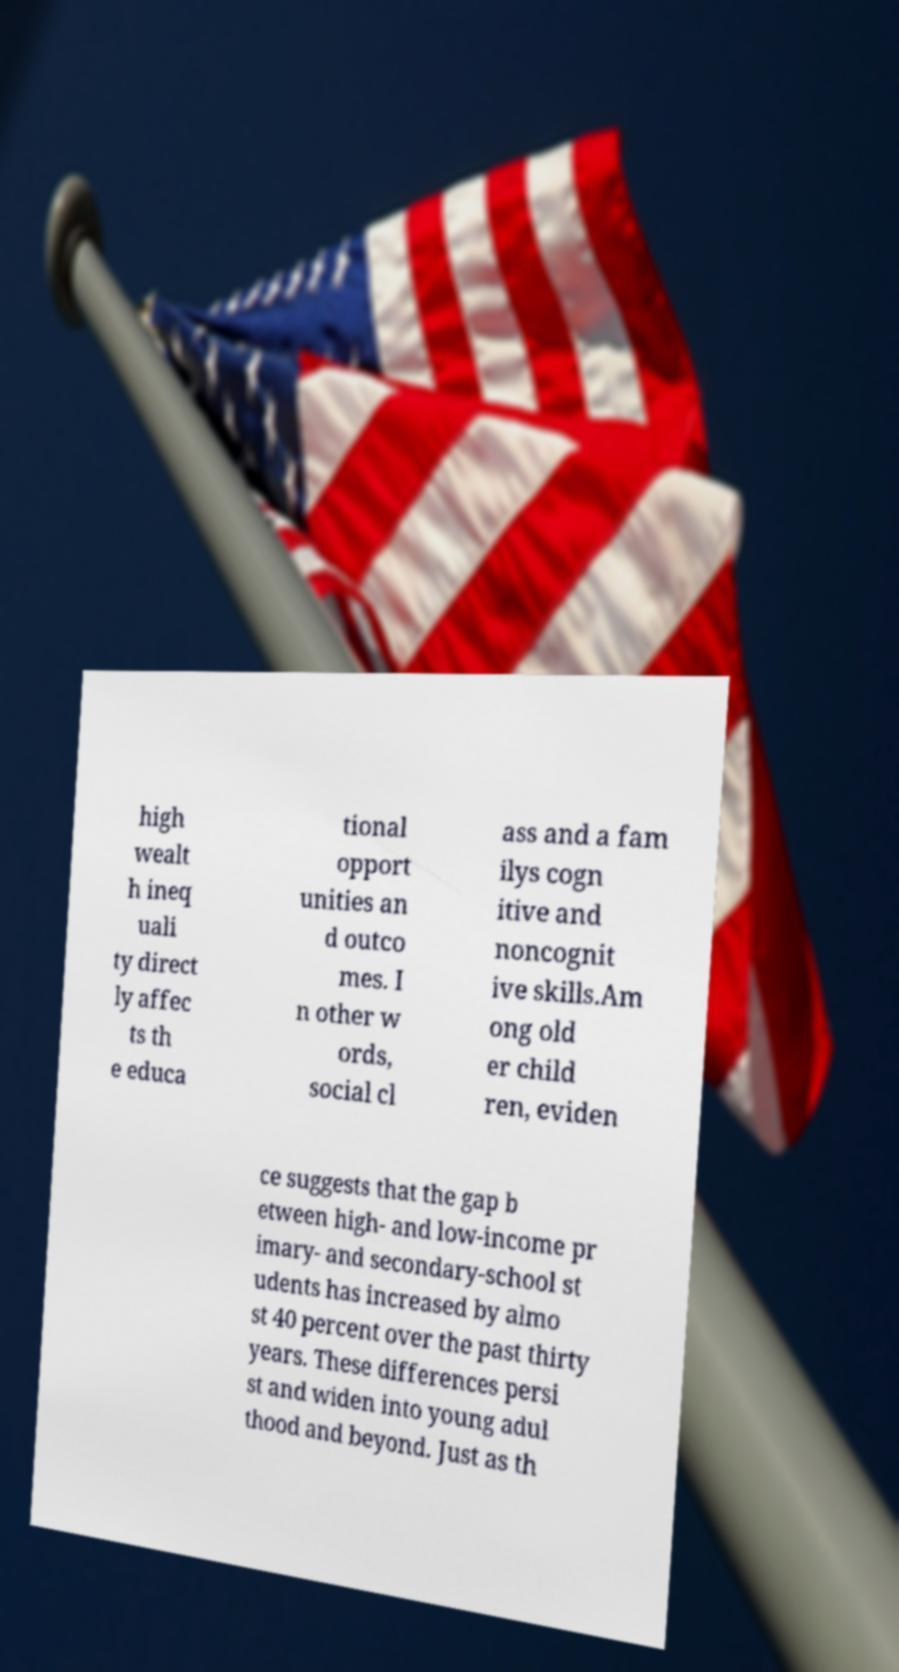Could you extract and type out the text from this image? high wealt h ineq uali ty direct ly affec ts th e educa tional opport unities an d outco mes. I n other w ords, social cl ass and a fam ilys cogn itive and noncognit ive skills.Am ong old er child ren, eviden ce suggests that the gap b etween high- and low-income pr imary- and secondary-school st udents has increased by almo st 40 percent over the past thirty years. These differences persi st and widen into young adul thood and beyond. Just as th 